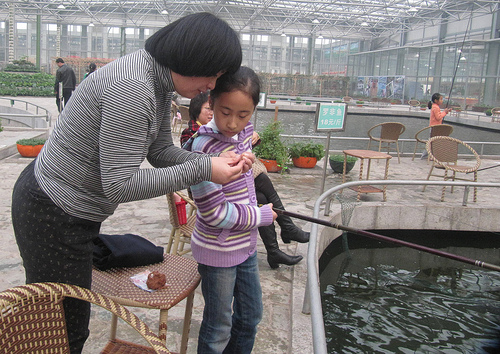<image>
Is there a lady on the girl? No. The lady is not positioned on the girl. They may be near each other, but the lady is not supported by or resting on top of the girl. 